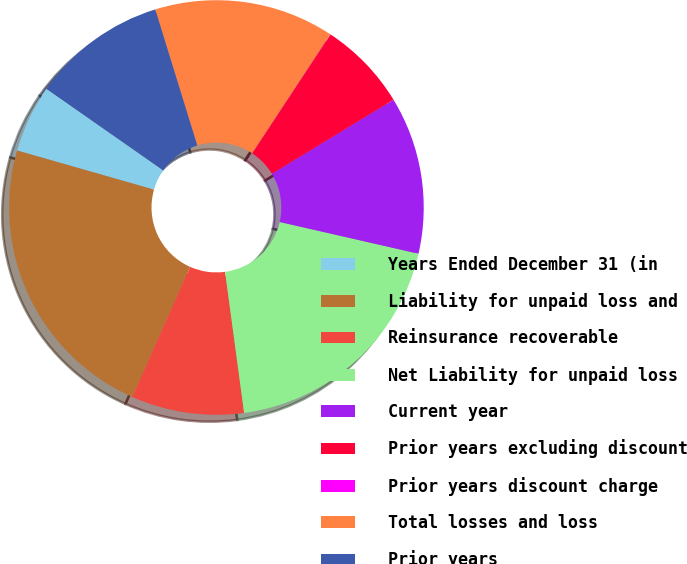Convert chart to OTSL. <chart><loc_0><loc_0><loc_500><loc_500><pie_chart><fcel>Years Ended December 31 (in<fcel>Liability for unpaid loss and<fcel>Reinsurance recoverable<fcel>Net Liability for unpaid loss<fcel>Current year<fcel>Prior years excluding discount<fcel>Prior years discount charge<fcel>Total losses and loss<fcel>Prior years<nl><fcel>5.27%<fcel>22.79%<fcel>8.78%<fcel>19.29%<fcel>12.28%<fcel>7.02%<fcel>0.02%<fcel>14.03%<fcel>10.53%<nl></chart> 